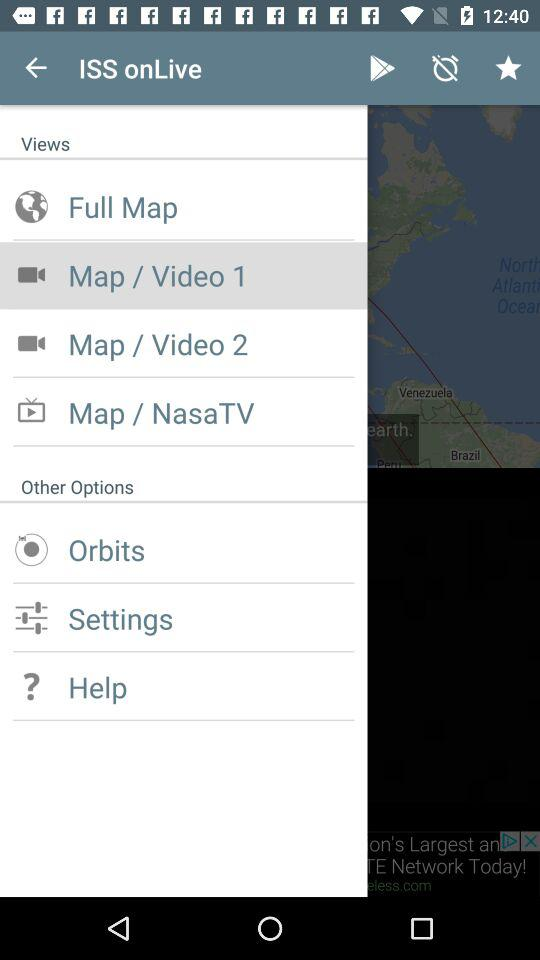How many video options are there?
Answer the question using a single word or phrase. 2 